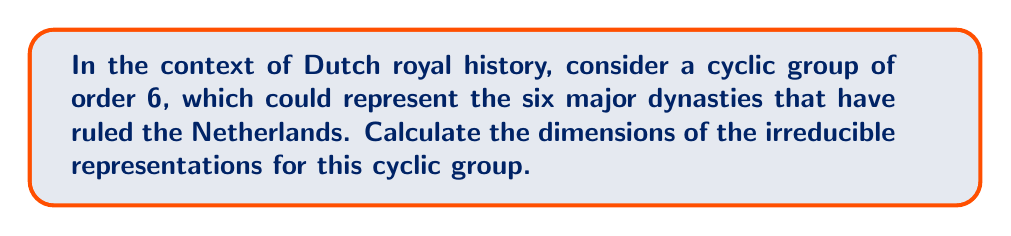Can you answer this question? To calculate the dimensions of irreducible representations for the cyclic group of order 6, we'll follow these steps:

1. Recall that for a cyclic group $C_n$ of order $n$, there are exactly $n$ irreducible representations, each of dimension 1.

2. The cyclic group $C_6$ is abelian, and for abelian groups, all irreducible representations are 1-dimensional.

3. The irreducible representations of $C_6$ are given by the group characters $\chi_k : C_6 \to \mathbb{C}^*$, where $k = 0, 1, 2, 3, 4, 5$.

4. For a generator $g$ of $C_6$, these characters are defined as:

   $\chi_k(g^j) = e^{2\pi i k j / 6}$, where $j = 0, 1, 2, 3, 4, 5$

5. Each of these characters corresponds to a 1-dimensional irreducible representation.

6. Therefore, we have six 1-dimensional irreducible representations:
   
   $\rho_0, \rho_1, \rho_2, \rho_3, \rho_4, \rho_5$

7. The dimension of each irreducible representation is 1.

Thus, the cyclic group of order 6 has six irreducible representations, each of dimension 1.
Answer: $\text{dim}(\rho_k) = 1$ for $k = 0, 1, 2, 3, 4, 5$ 